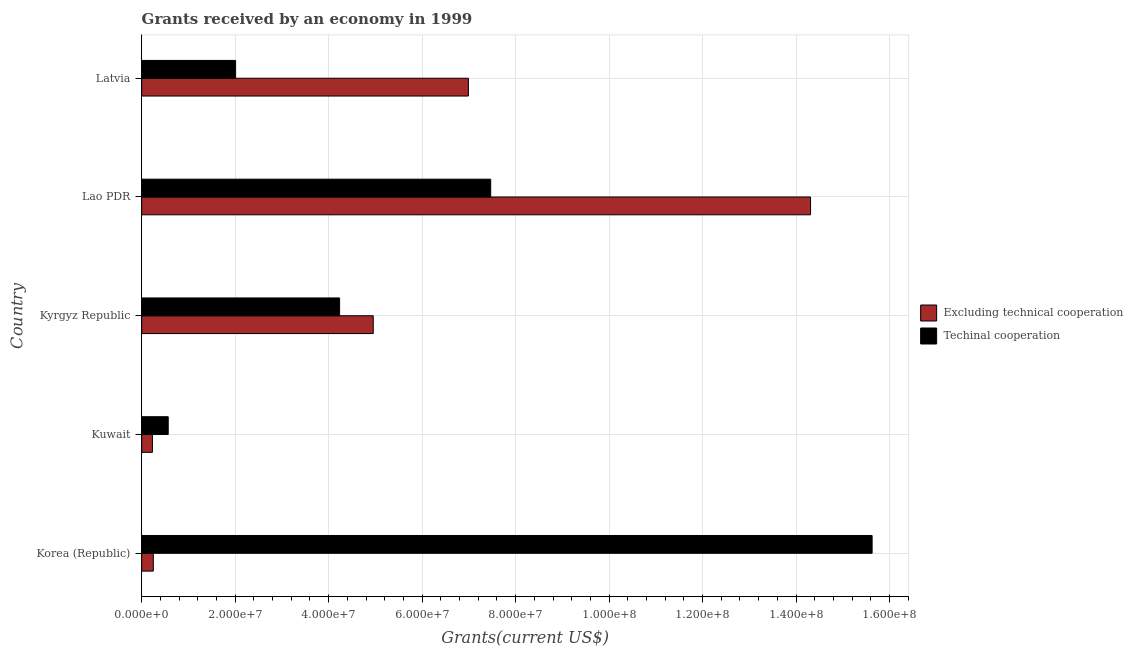How many different coloured bars are there?
Your answer should be compact. 2. How many groups of bars are there?
Keep it short and to the point. 5. Are the number of bars on each tick of the Y-axis equal?
Make the answer very short. Yes. How many bars are there on the 1st tick from the top?
Offer a terse response. 2. How many bars are there on the 5th tick from the bottom?
Make the answer very short. 2. What is the label of the 5th group of bars from the top?
Keep it short and to the point. Korea (Republic). In how many cases, is the number of bars for a given country not equal to the number of legend labels?
Provide a short and direct response. 0. What is the amount of grants received(excluding technical cooperation) in Kyrgyz Republic?
Keep it short and to the point. 4.95e+07. Across all countries, what is the maximum amount of grants received(excluding technical cooperation)?
Your answer should be very brief. 1.43e+08. Across all countries, what is the minimum amount of grants received(excluding technical cooperation)?
Offer a very short reply. 2.29e+06. In which country was the amount of grants received(including technical cooperation) maximum?
Offer a terse response. Korea (Republic). In which country was the amount of grants received(including technical cooperation) minimum?
Make the answer very short. Kuwait. What is the total amount of grants received(excluding technical cooperation) in the graph?
Your response must be concise. 2.67e+08. What is the difference between the amount of grants received(excluding technical cooperation) in Korea (Republic) and that in Latvia?
Keep it short and to the point. -6.74e+07. What is the difference between the amount of grants received(including technical cooperation) in Latvia and the amount of grants received(excluding technical cooperation) in Korea (Republic)?
Offer a terse response. 1.76e+07. What is the average amount of grants received(including technical cooperation) per country?
Offer a very short reply. 5.98e+07. What is the difference between the amount of grants received(including technical cooperation) and amount of grants received(excluding technical cooperation) in Latvia?
Make the answer very short. -4.98e+07. What is the ratio of the amount of grants received(including technical cooperation) in Kuwait to that in Latvia?
Your answer should be compact. 0.28. Is the difference between the amount of grants received(including technical cooperation) in Kuwait and Lao PDR greater than the difference between the amount of grants received(excluding technical cooperation) in Kuwait and Lao PDR?
Make the answer very short. Yes. What is the difference between the highest and the second highest amount of grants received(including technical cooperation)?
Provide a short and direct response. 8.16e+07. What is the difference between the highest and the lowest amount of grants received(excluding technical cooperation)?
Offer a terse response. 1.41e+08. In how many countries, is the amount of grants received(including technical cooperation) greater than the average amount of grants received(including technical cooperation) taken over all countries?
Your answer should be very brief. 2. Is the sum of the amount of grants received(including technical cooperation) in Kuwait and Lao PDR greater than the maximum amount of grants received(excluding technical cooperation) across all countries?
Your answer should be very brief. No. What does the 1st bar from the top in Kuwait represents?
Your response must be concise. Techinal cooperation. What does the 1st bar from the bottom in Kuwait represents?
Keep it short and to the point. Excluding technical cooperation. Are all the bars in the graph horizontal?
Offer a very short reply. Yes. How many countries are there in the graph?
Offer a very short reply. 5. What is the title of the graph?
Your response must be concise. Grants received by an economy in 1999. What is the label or title of the X-axis?
Provide a short and direct response. Grants(current US$). What is the Grants(current US$) of Excluding technical cooperation in Korea (Republic)?
Give a very brief answer. 2.48e+06. What is the Grants(current US$) in Techinal cooperation in Korea (Republic)?
Your answer should be compact. 1.56e+08. What is the Grants(current US$) in Excluding technical cooperation in Kuwait?
Provide a short and direct response. 2.29e+06. What is the Grants(current US$) of Techinal cooperation in Kuwait?
Keep it short and to the point. 5.67e+06. What is the Grants(current US$) of Excluding technical cooperation in Kyrgyz Republic?
Offer a very short reply. 4.95e+07. What is the Grants(current US$) of Techinal cooperation in Kyrgyz Republic?
Keep it short and to the point. 4.23e+07. What is the Grants(current US$) in Excluding technical cooperation in Lao PDR?
Offer a terse response. 1.43e+08. What is the Grants(current US$) of Techinal cooperation in Lao PDR?
Keep it short and to the point. 7.47e+07. What is the Grants(current US$) in Excluding technical cooperation in Latvia?
Your answer should be very brief. 6.99e+07. What is the Grants(current US$) of Techinal cooperation in Latvia?
Keep it short and to the point. 2.01e+07. Across all countries, what is the maximum Grants(current US$) of Excluding technical cooperation?
Make the answer very short. 1.43e+08. Across all countries, what is the maximum Grants(current US$) in Techinal cooperation?
Offer a very short reply. 1.56e+08. Across all countries, what is the minimum Grants(current US$) in Excluding technical cooperation?
Your answer should be compact. 2.29e+06. Across all countries, what is the minimum Grants(current US$) of Techinal cooperation?
Give a very brief answer. 5.67e+06. What is the total Grants(current US$) of Excluding technical cooperation in the graph?
Your answer should be very brief. 2.67e+08. What is the total Grants(current US$) in Techinal cooperation in the graph?
Keep it short and to the point. 2.99e+08. What is the difference between the Grants(current US$) in Techinal cooperation in Korea (Republic) and that in Kuwait?
Ensure brevity in your answer.  1.51e+08. What is the difference between the Grants(current US$) of Excluding technical cooperation in Korea (Republic) and that in Kyrgyz Republic?
Keep it short and to the point. -4.71e+07. What is the difference between the Grants(current US$) of Techinal cooperation in Korea (Republic) and that in Kyrgyz Republic?
Your answer should be compact. 1.14e+08. What is the difference between the Grants(current US$) of Excluding technical cooperation in Korea (Republic) and that in Lao PDR?
Offer a terse response. -1.41e+08. What is the difference between the Grants(current US$) of Techinal cooperation in Korea (Republic) and that in Lao PDR?
Your answer should be very brief. 8.16e+07. What is the difference between the Grants(current US$) of Excluding technical cooperation in Korea (Republic) and that in Latvia?
Your response must be concise. -6.74e+07. What is the difference between the Grants(current US$) in Techinal cooperation in Korea (Republic) and that in Latvia?
Give a very brief answer. 1.36e+08. What is the difference between the Grants(current US$) of Excluding technical cooperation in Kuwait and that in Kyrgyz Republic?
Keep it short and to the point. -4.72e+07. What is the difference between the Grants(current US$) of Techinal cooperation in Kuwait and that in Kyrgyz Republic?
Your response must be concise. -3.67e+07. What is the difference between the Grants(current US$) in Excluding technical cooperation in Kuwait and that in Lao PDR?
Give a very brief answer. -1.41e+08. What is the difference between the Grants(current US$) in Techinal cooperation in Kuwait and that in Lao PDR?
Make the answer very short. -6.90e+07. What is the difference between the Grants(current US$) of Excluding technical cooperation in Kuwait and that in Latvia?
Keep it short and to the point. -6.76e+07. What is the difference between the Grants(current US$) of Techinal cooperation in Kuwait and that in Latvia?
Make the answer very short. -1.44e+07. What is the difference between the Grants(current US$) in Excluding technical cooperation in Kyrgyz Republic and that in Lao PDR?
Offer a very short reply. -9.36e+07. What is the difference between the Grants(current US$) of Techinal cooperation in Kyrgyz Republic and that in Lao PDR?
Provide a short and direct response. -3.23e+07. What is the difference between the Grants(current US$) in Excluding technical cooperation in Kyrgyz Republic and that in Latvia?
Provide a short and direct response. -2.04e+07. What is the difference between the Grants(current US$) in Techinal cooperation in Kyrgyz Republic and that in Latvia?
Offer a terse response. 2.22e+07. What is the difference between the Grants(current US$) of Excluding technical cooperation in Lao PDR and that in Latvia?
Your answer should be compact. 7.32e+07. What is the difference between the Grants(current US$) in Techinal cooperation in Lao PDR and that in Latvia?
Your answer should be compact. 5.46e+07. What is the difference between the Grants(current US$) of Excluding technical cooperation in Korea (Republic) and the Grants(current US$) of Techinal cooperation in Kuwait?
Your answer should be very brief. -3.19e+06. What is the difference between the Grants(current US$) of Excluding technical cooperation in Korea (Republic) and the Grants(current US$) of Techinal cooperation in Kyrgyz Republic?
Provide a short and direct response. -3.99e+07. What is the difference between the Grants(current US$) of Excluding technical cooperation in Korea (Republic) and the Grants(current US$) of Techinal cooperation in Lao PDR?
Provide a short and direct response. -7.22e+07. What is the difference between the Grants(current US$) in Excluding technical cooperation in Korea (Republic) and the Grants(current US$) in Techinal cooperation in Latvia?
Your answer should be very brief. -1.76e+07. What is the difference between the Grants(current US$) of Excluding technical cooperation in Kuwait and the Grants(current US$) of Techinal cooperation in Kyrgyz Republic?
Make the answer very short. -4.00e+07. What is the difference between the Grants(current US$) of Excluding technical cooperation in Kuwait and the Grants(current US$) of Techinal cooperation in Lao PDR?
Your response must be concise. -7.24e+07. What is the difference between the Grants(current US$) of Excluding technical cooperation in Kuwait and the Grants(current US$) of Techinal cooperation in Latvia?
Make the answer very short. -1.78e+07. What is the difference between the Grants(current US$) in Excluding technical cooperation in Kyrgyz Republic and the Grants(current US$) in Techinal cooperation in Lao PDR?
Your response must be concise. -2.51e+07. What is the difference between the Grants(current US$) in Excluding technical cooperation in Kyrgyz Republic and the Grants(current US$) in Techinal cooperation in Latvia?
Offer a terse response. 2.94e+07. What is the difference between the Grants(current US$) in Excluding technical cooperation in Lao PDR and the Grants(current US$) in Techinal cooperation in Latvia?
Provide a succinct answer. 1.23e+08. What is the average Grants(current US$) in Excluding technical cooperation per country?
Provide a short and direct response. 5.35e+07. What is the average Grants(current US$) in Techinal cooperation per country?
Your answer should be compact. 5.98e+07. What is the difference between the Grants(current US$) in Excluding technical cooperation and Grants(current US$) in Techinal cooperation in Korea (Republic)?
Ensure brevity in your answer.  -1.54e+08. What is the difference between the Grants(current US$) in Excluding technical cooperation and Grants(current US$) in Techinal cooperation in Kuwait?
Provide a succinct answer. -3.38e+06. What is the difference between the Grants(current US$) of Excluding technical cooperation and Grants(current US$) of Techinal cooperation in Kyrgyz Republic?
Provide a short and direct response. 7.20e+06. What is the difference between the Grants(current US$) of Excluding technical cooperation and Grants(current US$) of Techinal cooperation in Lao PDR?
Offer a terse response. 6.84e+07. What is the difference between the Grants(current US$) of Excluding technical cooperation and Grants(current US$) of Techinal cooperation in Latvia?
Offer a very short reply. 4.98e+07. What is the ratio of the Grants(current US$) of Excluding technical cooperation in Korea (Republic) to that in Kuwait?
Your response must be concise. 1.08. What is the ratio of the Grants(current US$) in Techinal cooperation in Korea (Republic) to that in Kuwait?
Your answer should be compact. 27.56. What is the ratio of the Grants(current US$) of Excluding technical cooperation in Korea (Republic) to that in Kyrgyz Republic?
Offer a terse response. 0.05. What is the ratio of the Grants(current US$) of Techinal cooperation in Korea (Republic) to that in Kyrgyz Republic?
Give a very brief answer. 3.69. What is the ratio of the Grants(current US$) of Excluding technical cooperation in Korea (Republic) to that in Lao PDR?
Keep it short and to the point. 0.02. What is the ratio of the Grants(current US$) in Techinal cooperation in Korea (Republic) to that in Lao PDR?
Ensure brevity in your answer.  2.09. What is the ratio of the Grants(current US$) in Excluding technical cooperation in Korea (Republic) to that in Latvia?
Provide a succinct answer. 0.04. What is the ratio of the Grants(current US$) in Techinal cooperation in Korea (Republic) to that in Latvia?
Ensure brevity in your answer.  7.78. What is the ratio of the Grants(current US$) in Excluding technical cooperation in Kuwait to that in Kyrgyz Republic?
Provide a succinct answer. 0.05. What is the ratio of the Grants(current US$) in Techinal cooperation in Kuwait to that in Kyrgyz Republic?
Offer a very short reply. 0.13. What is the ratio of the Grants(current US$) in Excluding technical cooperation in Kuwait to that in Lao PDR?
Make the answer very short. 0.02. What is the ratio of the Grants(current US$) in Techinal cooperation in Kuwait to that in Lao PDR?
Your answer should be very brief. 0.08. What is the ratio of the Grants(current US$) in Excluding technical cooperation in Kuwait to that in Latvia?
Your answer should be compact. 0.03. What is the ratio of the Grants(current US$) of Techinal cooperation in Kuwait to that in Latvia?
Your answer should be compact. 0.28. What is the ratio of the Grants(current US$) in Excluding technical cooperation in Kyrgyz Republic to that in Lao PDR?
Keep it short and to the point. 0.35. What is the ratio of the Grants(current US$) of Techinal cooperation in Kyrgyz Republic to that in Lao PDR?
Make the answer very short. 0.57. What is the ratio of the Grants(current US$) in Excluding technical cooperation in Kyrgyz Republic to that in Latvia?
Offer a very short reply. 0.71. What is the ratio of the Grants(current US$) in Techinal cooperation in Kyrgyz Republic to that in Latvia?
Your response must be concise. 2.11. What is the ratio of the Grants(current US$) of Excluding technical cooperation in Lao PDR to that in Latvia?
Your answer should be compact. 2.05. What is the ratio of the Grants(current US$) of Techinal cooperation in Lao PDR to that in Latvia?
Give a very brief answer. 3.72. What is the difference between the highest and the second highest Grants(current US$) in Excluding technical cooperation?
Your answer should be compact. 7.32e+07. What is the difference between the highest and the second highest Grants(current US$) of Techinal cooperation?
Make the answer very short. 8.16e+07. What is the difference between the highest and the lowest Grants(current US$) of Excluding technical cooperation?
Your answer should be very brief. 1.41e+08. What is the difference between the highest and the lowest Grants(current US$) in Techinal cooperation?
Make the answer very short. 1.51e+08. 